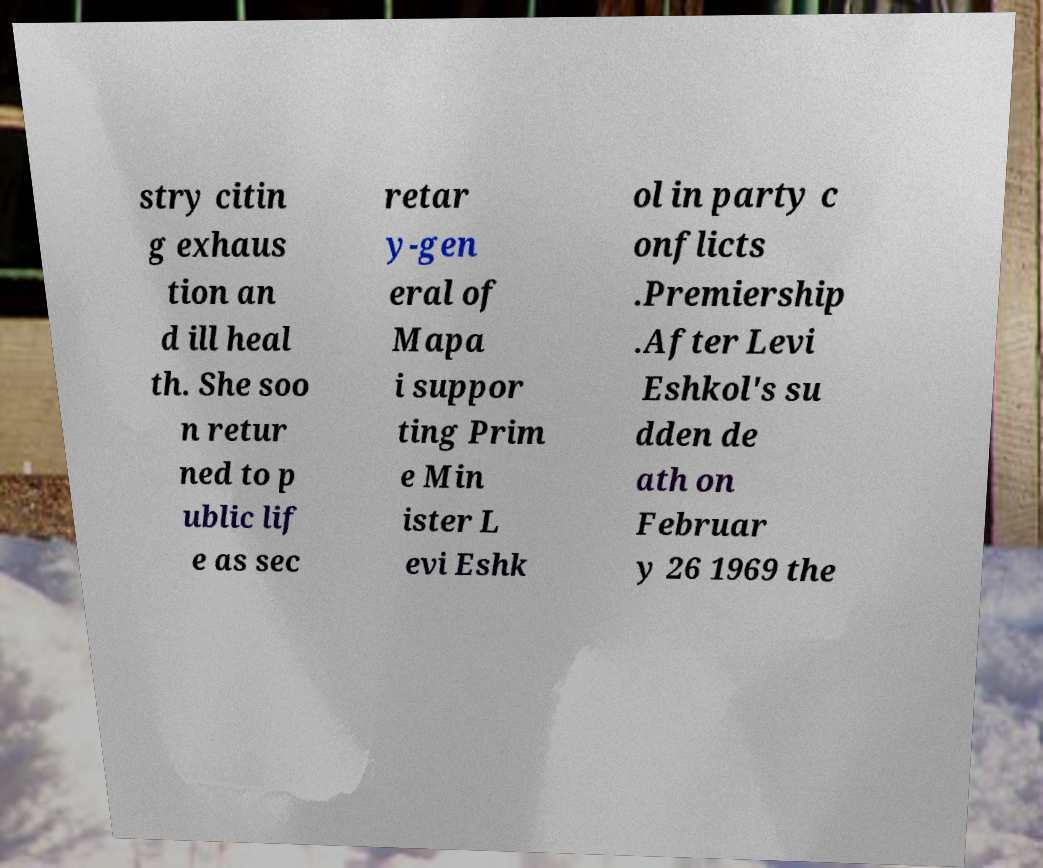For documentation purposes, I need the text within this image transcribed. Could you provide that? stry citin g exhaus tion an d ill heal th. She soo n retur ned to p ublic lif e as sec retar y-gen eral of Mapa i suppor ting Prim e Min ister L evi Eshk ol in party c onflicts .Premiership .After Levi Eshkol's su dden de ath on Februar y 26 1969 the 